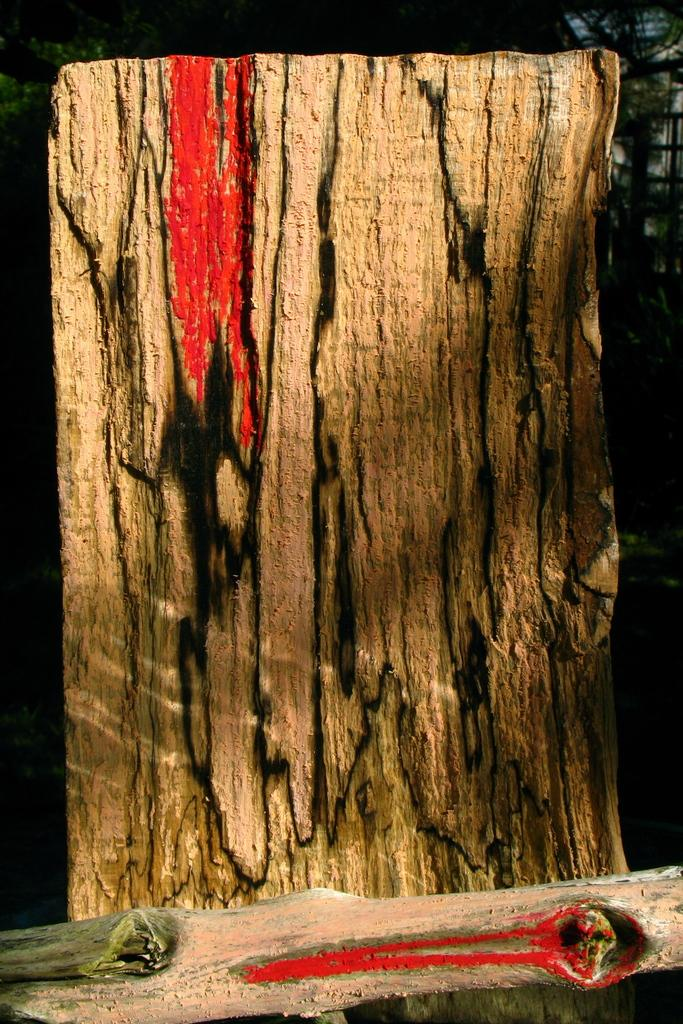What type of material are the logs made of in the image? The logs in the image are made of wood. Can you describe the appearance of the logs? The wooden logs have red colored paint on them. What can be seen in the background of the image? There are trees in the background of the background of the image. What type of crook is using the apparatus to grade the logs in the image? There is no crook, apparatus, or grading activity present in the image. 